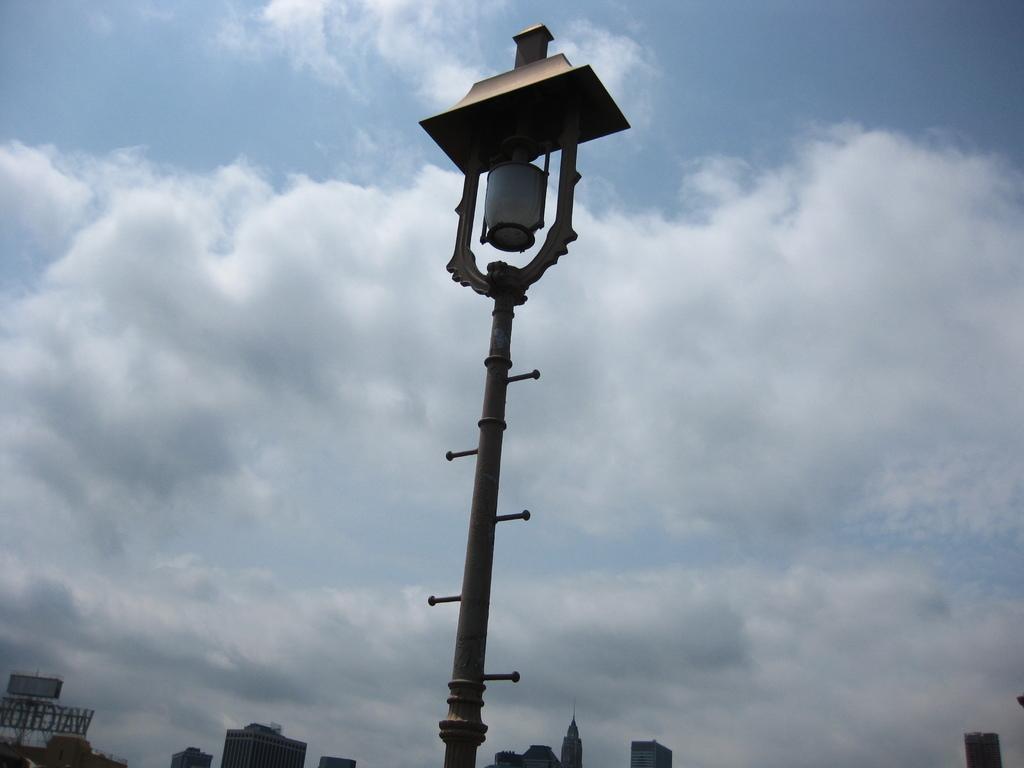Please provide a concise description of this image. In this image there is a pole, in the background there are buildings and a cloudy sky. 